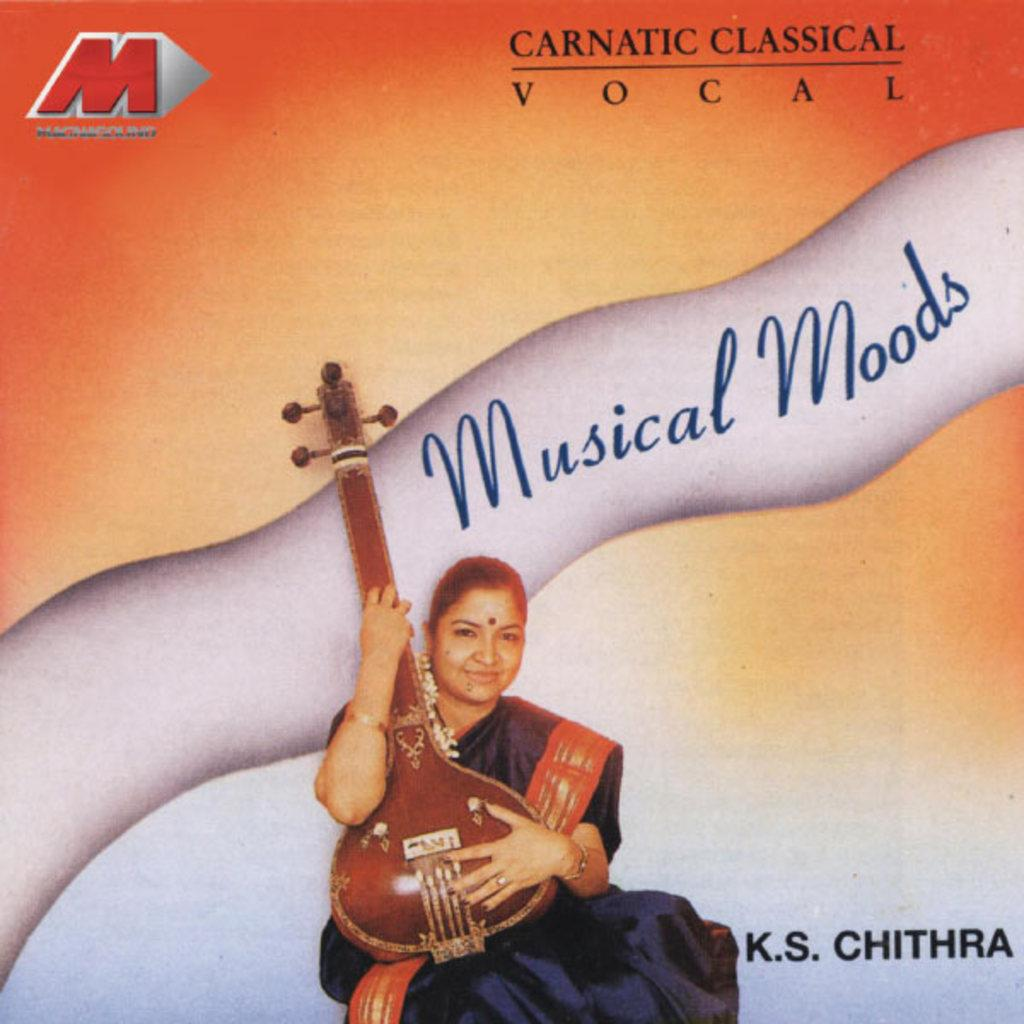What type of image is being described? The image is a poster. What is the main subject of the poster? There is a woman sitting in the center of the poster. What is the woman doing in the poster? The woman is holding a musical instrument. Where can text be found on the poster? There is text in the center of the poster and at the top of the poster. What type of cheese is being used to create the slope in the image? There is no cheese or slope present in the image; it features a woman holding a musical instrument and text on a poster. What kind of haircut does the woman have in the image? The provided facts do not mention the woman's haircut, so we cannot determine her hairstyle from the image. 